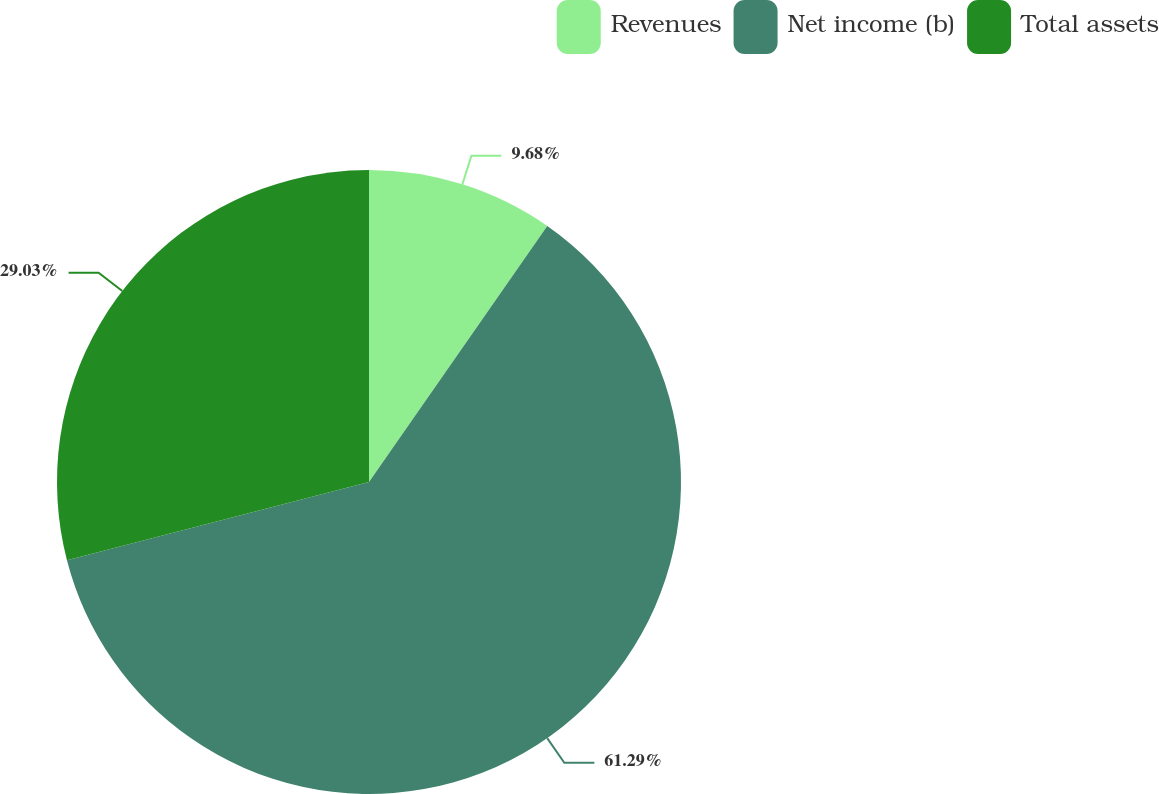Convert chart. <chart><loc_0><loc_0><loc_500><loc_500><pie_chart><fcel>Revenues<fcel>Net income (b)<fcel>Total assets<nl><fcel>9.68%<fcel>61.29%<fcel>29.03%<nl></chart> 